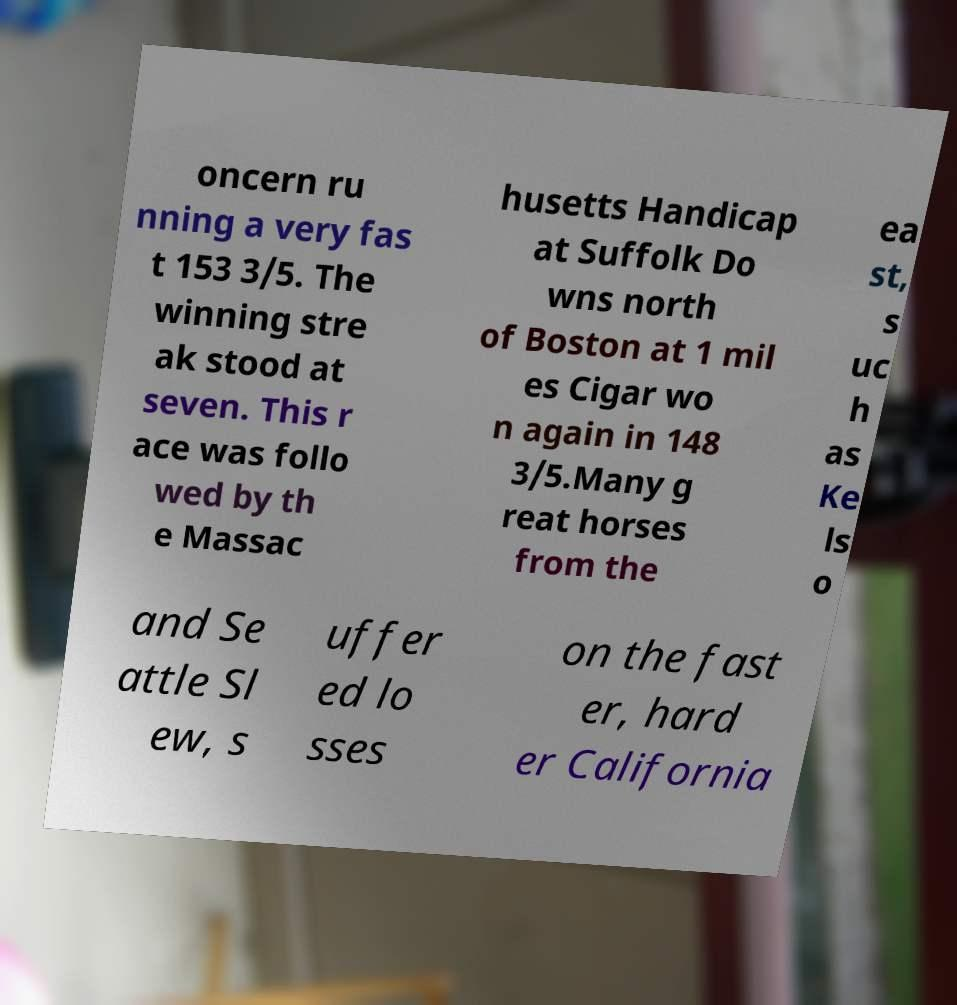There's text embedded in this image that I need extracted. Can you transcribe it verbatim? oncern ru nning a very fas t 153 3/5. The winning stre ak stood at seven. This r ace was follo wed by th e Massac husetts Handicap at Suffolk Do wns north of Boston at 1 mil es Cigar wo n again in 148 3/5.Many g reat horses from the ea st, s uc h as Ke ls o and Se attle Sl ew, s uffer ed lo sses on the fast er, hard er California 